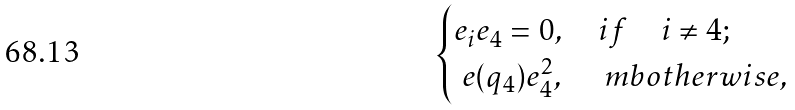Convert formula to latex. <formula><loc_0><loc_0><loc_500><loc_500>\begin{cases} e _ { i } e _ { 4 } = 0 , \quad i f \quad i \not = 4 ; \\ \ e ( q _ { 4 } ) e _ { 4 } ^ { 2 } , \quad \ m b { o t h e r w i s e } , \end{cases}</formula> 